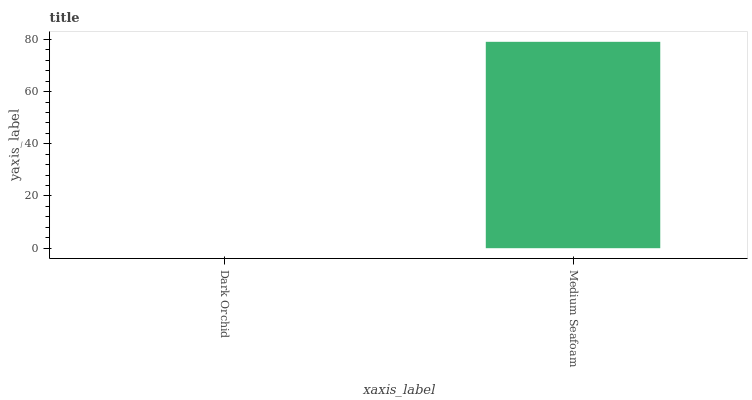Is Medium Seafoam the minimum?
Answer yes or no. No. Is Medium Seafoam greater than Dark Orchid?
Answer yes or no. Yes. Is Dark Orchid less than Medium Seafoam?
Answer yes or no. Yes. Is Dark Orchid greater than Medium Seafoam?
Answer yes or no. No. Is Medium Seafoam less than Dark Orchid?
Answer yes or no. No. Is Medium Seafoam the high median?
Answer yes or no. Yes. Is Dark Orchid the low median?
Answer yes or no. Yes. Is Dark Orchid the high median?
Answer yes or no. No. Is Medium Seafoam the low median?
Answer yes or no. No. 